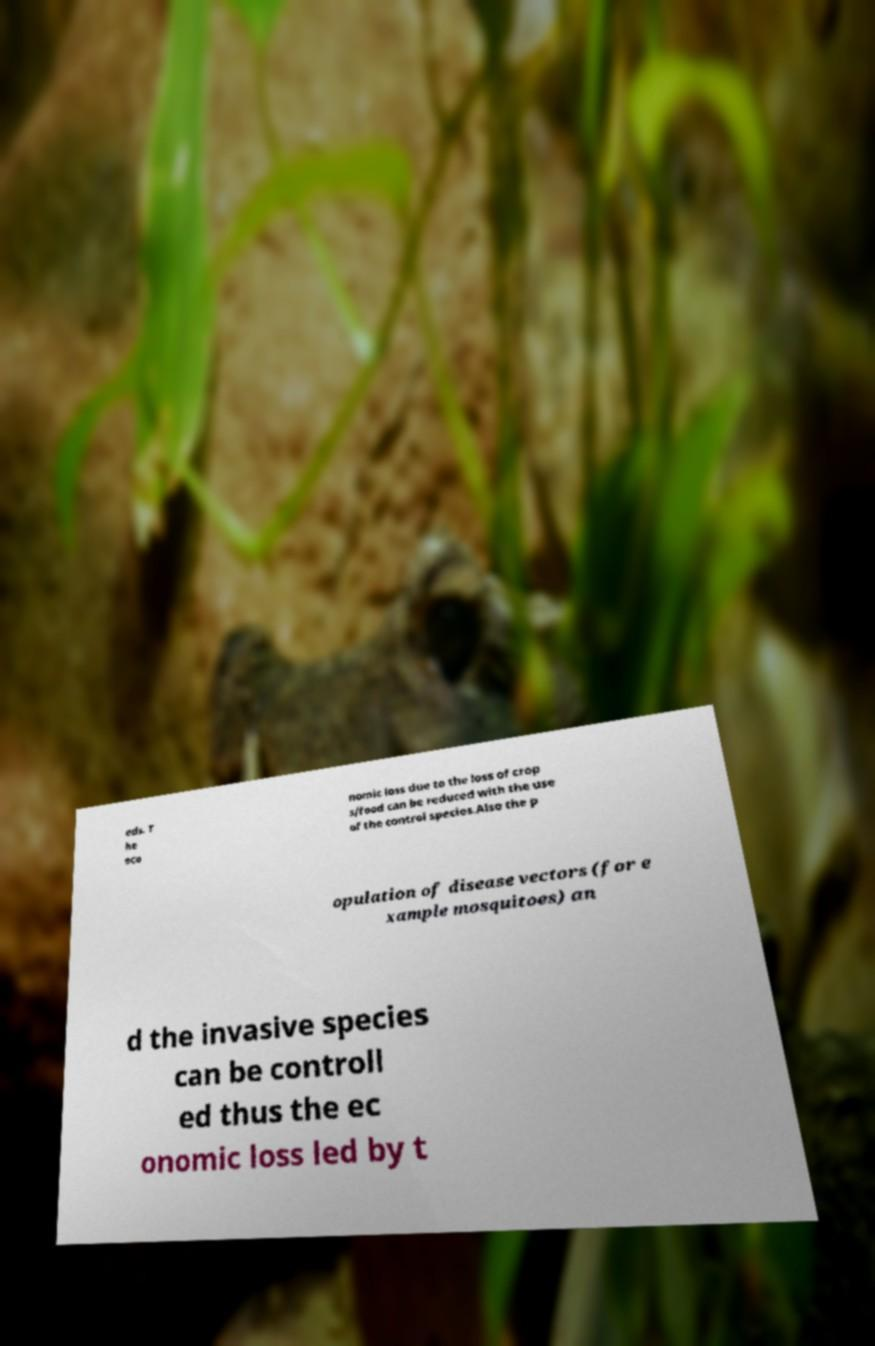Please identify and transcribe the text found in this image. eds. T he eco nomic loss due to the loss of crop s/food can be reduced with the use of the control species.Also the p opulation of disease vectors (for e xample mosquitoes) an d the invasive species can be controll ed thus the ec onomic loss led by t 